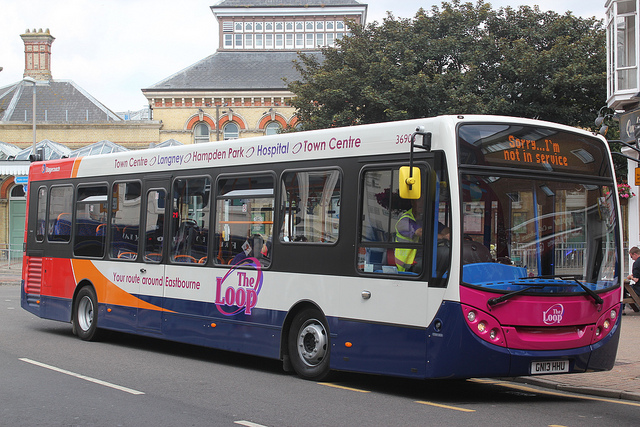Identify the text contained in this image. Town Centre langney Hampden Pork Hospital Service in not I'm Sorry Eastbourne around route Your Loop The HHU GNI3 The Loop 3690 Centre Town 